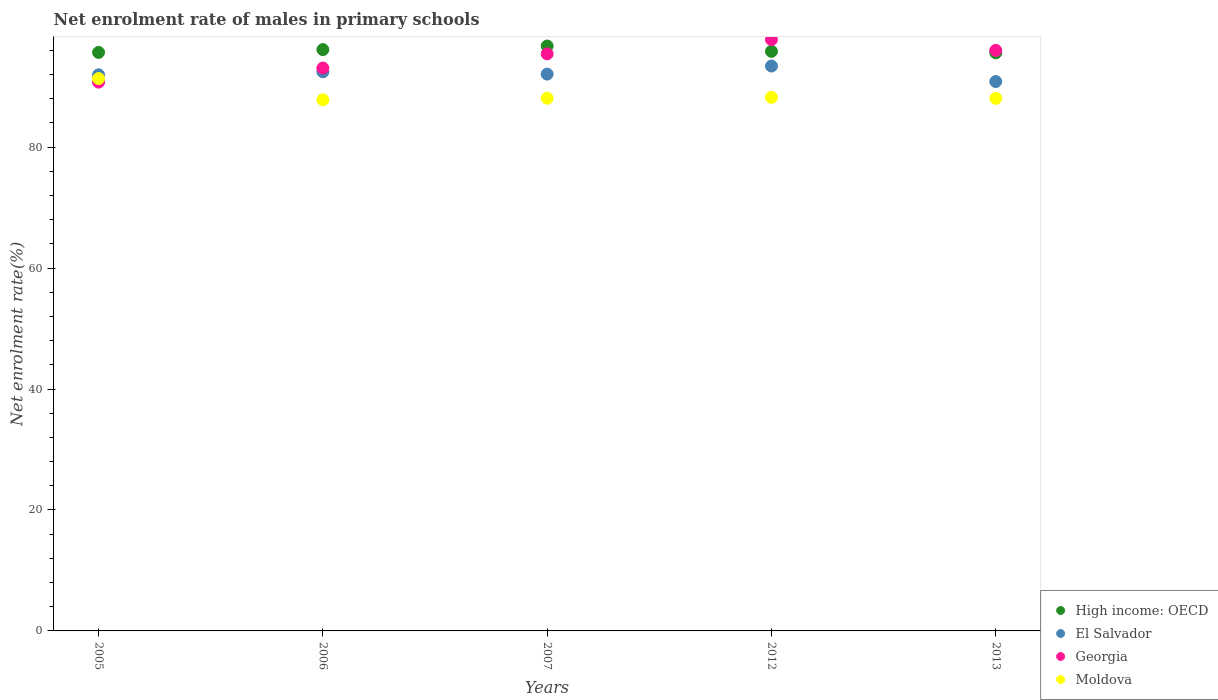How many different coloured dotlines are there?
Provide a short and direct response. 4. What is the net enrolment rate of males in primary schools in High income: OECD in 2005?
Keep it short and to the point. 95.67. Across all years, what is the maximum net enrolment rate of males in primary schools in El Salvador?
Your answer should be compact. 93.41. Across all years, what is the minimum net enrolment rate of males in primary schools in Moldova?
Offer a terse response. 87.82. What is the total net enrolment rate of males in primary schools in High income: OECD in the graph?
Provide a short and direct response. 479.97. What is the difference between the net enrolment rate of males in primary schools in Georgia in 2005 and that in 2007?
Provide a succinct answer. -4.67. What is the difference between the net enrolment rate of males in primary schools in High income: OECD in 2005 and the net enrolment rate of males in primary schools in Moldova in 2007?
Offer a terse response. 7.58. What is the average net enrolment rate of males in primary schools in Moldova per year?
Ensure brevity in your answer.  88.71. In the year 2013, what is the difference between the net enrolment rate of males in primary schools in Georgia and net enrolment rate of males in primary schools in El Salvador?
Provide a short and direct response. 5.15. What is the ratio of the net enrolment rate of males in primary schools in Georgia in 2006 to that in 2012?
Give a very brief answer. 0.95. Is the net enrolment rate of males in primary schools in Georgia in 2007 less than that in 2013?
Give a very brief answer. Yes. What is the difference between the highest and the second highest net enrolment rate of males in primary schools in High income: OECD?
Your answer should be very brief. 0.59. What is the difference between the highest and the lowest net enrolment rate of males in primary schools in Georgia?
Your response must be concise. 7.03. In how many years, is the net enrolment rate of males in primary schools in El Salvador greater than the average net enrolment rate of males in primary schools in El Salvador taken over all years?
Provide a succinct answer. 2. Does the net enrolment rate of males in primary schools in El Salvador monotonically increase over the years?
Make the answer very short. No. Is the net enrolment rate of males in primary schools in Georgia strictly less than the net enrolment rate of males in primary schools in El Salvador over the years?
Ensure brevity in your answer.  No. How many years are there in the graph?
Your answer should be very brief. 5. Does the graph contain any zero values?
Your answer should be very brief. No. Does the graph contain grids?
Your response must be concise. No. What is the title of the graph?
Your answer should be very brief. Net enrolment rate of males in primary schools. What is the label or title of the X-axis?
Your response must be concise. Years. What is the label or title of the Y-axis?
Give a very brief answer. Net enrolment rate(%). What is the Net enrolment rate(%) in High income: OECD in 2005?
Your answer should be compact. 95.67. What is the Net enrolment rate(%) in El Salvador in 2005?
Offer a very short reply. 91.96. What is the Net enrolment rate(%) in Georgia in 2005?
Make the answer very short. 90.75. What is the Net enrolment rate(%) in Moldova in 2005?
Make the answer very short. 91.34. What is the Net enrolment rate(%) of High income: OECD in 2006?
Offer a terse response. 96.13. What is the Net enrolment rate(%) in El Salvador in 2006?
Ensure brevity in your answer.  92.46. What is the Net enrolment rate(%) of Georgia in 2006?
Offer a very short reply. 93.08. What is the Net enrolment rate(%) of Moldova in 2006?
Provide a succinct answer. 87.82. What is the Net enrolment rate(%) of High income: OECD in 2007?
Provide a short and direct response. 96.72. What is the Net enrolment rate(%) in El Salvador in 2007?
Ensure brevity in your answer.  92.08. What is the Net enrolment rate(%) in Georgia in 2007?
Provide a succinct answer. 95.43. What is the Net enrolment rate(%) in Moldova in 2007?
Provide a short and direct response. 88.09. What is the Net enrolment rate(%) in High income: OECD in 2012?
Keep it short and to the point. 95.85. What is the Net enrolment rate(%) in El Salvador in 2012?
Ensure brevity in your answer.  93.41. What is the Net enrolment rate(%) of Georgia in 2012?
Your response must be concise. 97.79. What is the Net enrolment rate(%) in Moldova in 2012?
Keep it short and to the point. 88.23. What is the Net enrolment rate(%) in High income: OECD in 2013?
Your answer should be compact. 95.6. What is the Net enrolment rate(%) of El Salvador in 2013?
Make the answer very short. 90.85. What is the Net enrolment rate(%) of Georgia in 2013?
Your answer should be very brief. 96. What is the Net enrolment rate(%) of Moldova in 2013?
Provide a succinct answer. 88.07. Across all years, what is the maximum Net enrolment rate(%) in High income: OECD?
Provide a succinct answer. 96.72. Across all years, what is the maximum Net enrolment rate(%) of El Salvador?
Your answer should be compact. 93.41. Across all years, what is the maximum Net enrolment rate(%) in Georgia?
Your answer should be very brief. 97.79. Across all years, what is the maximum Net enrolment rate(%) in Moldova?
Your answer should be very brief. 91.34. Across all years, what is the minimum Net enrolment rate(%) of High income: OECD?
Offer a very short reply. 95.6. Across all years, what is the minimum Net enrolment rate(%) of El Salvador?
Offer a very short reply. 90.85. Across all years, what is the minimum Net enrolment rate(%) in Georgia?
Provide a short and direct response. 90.75. Across all years, what is the minimum Net enrolment rate(%) of Moldova?
Offer a terse response. 87.82. What is the total Net enrolment rate(%) in High income: OECD in the graph?
Offer a terse response. 479.97. What is the total Net enrolment rate(%) of El Salvador in the graph?
Offer a very short reply. 460.77. What is the total Net enrolment rate(%) in Georgia in the graph?
Your response must be concise. 473.05. What is the total Net enrolment rate(%) of Moldova in the graph?
Ensure brevity in your answer.  443.55. What is the difference between the Net enrolment rate(%) of High income: OECD in 2005 and that in 2006?
Offer a very short reply. -0.47. What is the difference between the Net enrolment rate(%) of El Salvador in 2005 and that in 2006?
Make the answer very short. -0.5. What is the difference between the Net enrolment rate(%) in Georgia in 2005 and that in 2006?
Make the answer very short. -2.33. What is the difference between the Net enrolment rate(%) in Moldova in 2005 and that in 2006?
Give a very brief answer. 3.52. What is the difference between the Net enrolment rate(%) of High income: OECD in 2005 and that in 2007?
Make the answer very short. -1.06. What is the difference between the Net enrolment rate(%) in El Salvador in 2005 and that in 2007?
Your answer should be compact. -0.12. What is the difference between the Net enrolment rate(%) in Georgia in 2005 and that in 2007?
Keep it short and to the point. -4.67. What is the difference between the Net enrolment rate(%) of Moldova in 2005 and that in 2007?
Offer a very short reply. 3.25. What is the difference between the Net enrolment rate(%) of High income: OECD in 2005 and that in 2012?
Your answer should be very brief. -0.18. What is the difference between the Net enrolment rate(%) of El Salvador in 2005 and that in 2012?
Your response must be concise. -1.45. What is the difference between the Net enrolment rate(%) in Georgia in 2005 and that in 2012?
Give a very brief answer. -7.03. What is the difference between the Net enrolment rate(%) of Moldova in 2005 and that in 2012?
Give a very brief answer. 3.11. What is the difference between the Net enrolment rate(%) of High income: OECD in 2005 and that in 2013?
Make the answer very short. 0.07. What is the difference between the Net enrolment rate(%) of El Salvador in 2005 and that in 2013?
Give a very brief answer. 1.11. What is the difference between the Net enrolment rate(%) in Georgia in 2005 and that in 2013?
Keep it short and to the point. -5.25. What is the difference between the Net enrolment rate(%) in Moldova in 2005 and that in 2013?
Provide a succinct answer. 3.27. What is the difference between the Net enrolment rate(%) of High income: OECD in 2006 and that in 2007?
Your response must be concise. -0.59. What is the difference between the Net enrolment rate(%) of El Salvador in 2006 and that in 2007?
Give a very brief answer. 0.38. What is the difference between the Net enrolment rate(%) of Georgia in 2006 and that in 2007?
Provide a succinct answer. -2.35. What is the difference between the Net enrolment rate(%) of Moldova in 2006 and that in 2007?
Make the answer very short. -0.27. What is the difference between the Net enrolment rate(%) in High income: OECD in 2006 and that in 2012?
Keep it short and to the point. 0.29. What is the difference between the Net enrolment rate(%) in El Salvador in 2006 and that in 2012?
Offer a very short reply. -0.95. What is the difference between the Net enrolment rate(%) in Georgia in 2006 and that in 2012?
Keep it short and to the point. -4.71. What is the difference between the Net enrolment rate(%) of Moldova in 2006 and that in 2012?
Your answer should be compact. -0.41. What is the difference between the Net enrolment rate(%) in High income: OECD in 2006 and that in 2013?
Your response must be concise. 0.54. What is the difference between the Net enrolment rate(%) in El Salvador in 2006 and that in 2013?
Keep it short and to the point. 1.61. What is the difference between the Net enrolment rate(%) in Georgia in 2006 and that in 2013?
Ensure brevity in your answer.  -2.92. What is the difference between the Net enrolment rate(%) of Moldova in 2006 and that in 2013?
Make the answer very short. -0.24. What is the difference between the Net enrolment rate(%) of High income: OECD in 2007 and that in 2012?
Offer a very short reply. 0.88. What is the difference between the Net enrolment rate(%) of El Salvador in 2007 and that in 2012?
Offer a very short reply. -1.33. What is the difference between the Net enrolment rate(%) in Georgia in 2007 and that in 2012?
Provide a short and direct response. -2.36. What is the difference between the Net enrolment rate(%) in Moldova in 2007 and that in 2012?
Ensure brevity in your answer.  -0.14. What is the difference between the Net enrolment rate(%) in High income: OECD in 2007 and that in 2013?
Make the answer very short. 1.13. What is the difference between the Net enrolment rate(%) of El Salvador in 2007 and that in 2013?
Make the answer very short. 1.23. What is the difference between the Net enrolment rate(%) of Georgia in 2007 and that in 2013?
Your answer should be compact. -0.58. What is the difference between the Net enrolment rate(%) of Moldova in 2007 and that in 2013?
Offer a very short reply. 0.02. What is the difference between the Net enrolment rate(%) of High income: OECD in 2012 and that in 2013?
Your answer should be very brief. 0.25. What is the difference between the Net enrolment rate(%) in El Salvador in 2012 and that in 2013?
Your answer should be compact. 2.56. What is the difference between the Net enrolment rate(%) of Georgia in 2012 and that in 2013?
Keep it short and to the point. 1.78. What is the difference between the Net enrolment rate(%) in Moldova in 2012 and that in 2013?
Provide a short and direct response. 0.16. What is the difference between the Net enrolment rate(%) in High income: OECD in 2005 and the Net enrolment rate(%) in El Salvador in 2006?
Make the answer very short. 3.2. What is the difference between the Net enrolment rate(%) in High income: OECD in 2005 and the Net enrolment rate(%) in Georgia in 2006?
Give a very brief answer. 2.58. What is the difference between the Net enrolment rate(%) in High income: OECD in 2005 and the Net enrolment rate(%) in Moldova in 2006?
Ensure brevity in your answer.  7.84. What is the difference between the Net enrolment rate(%) of El Salvador in 2005 and the Net enrolment rate(%) of Georgia in 2006?
Ensure brevity in your answer.  -1.12. What is the difference between the Net enrolment rate(%) of El Salvador in 2005 and the Net enrolment rate(%) of Moldova in 2006?
Provide a short and direct response. 4.14. What is the difference between the Net enrolment rate(%) in Georgia in 2005 and the Net enrolment rate(%) in Moldova in 2006?
Give a very brief answer. 2.93. What is the difference between the Net enrolment rate(%) of High income: OECD in 2005 and the Net enrolment rate(%) of El Salvador in 2007?
Offer a very short reply. 3.58. What is the difference between the Net enrolment rate(%) in High income: OECD in 2005 and the Net enrolment rate(%) in Georgia in 2007?
Provide a short and direct response. 0.24. What is the difference between the Net enrolment rate(%) in High income: OECD in 2005 and the Net enrolment rate(%) in Moldova in 2007?
Give a very brief answer. 7.58. What is the difference between the Net enrolment rate(%) of El Salvador in 2005 and the Net enrolment rate(%) of Georgia in 2007?
Make the answer very short. -3.46. What is the difference between the Net enrolment rate(%) in El Salvador in 2005 and the Net enrolment rate(%) in Moldova in 2007?
Make the answer very short. 3.88. What is the difference between the Net enrolment rate(%) in Georgia in 2005 and the Net enrolment rate(%) in Moldova in 2007?
Give a very brief answer. 2.67. What is the difference between the Net enrolment rate(%) of High income: OECD in 2005 and the Net enrolment rate(%) of El Salvador in 2012?
Keep it short and to the point. 2.25. What is the difference between the Net enrolment rate(%) in High income: OECD in 2005 and the Net enrolment rate(%) in Georgia in 2012?
Make the answer very short. -2.12. What is the difference between the Net enrolment rate(%) of High income: OECD in 2005 and the Net enrolment rate(%) of Moldova in 2012?
Offer a terse response. 7.44. What is the difference between the Net enrolment rate(%) in El Salvador in 2005 and the Net enrolment rate(%) in Georgia in 2012?
Your response must be concise. -5.82. What is the difference between the Net enrolment rate(%) of El Salvador in 2005 and the Net enrolment rate(%) of Moldova in 2012?
Give a very brief answer. 3.73. What is the difference between the Net enrolment rate(%) in Georgia in 2005 and the Net enrolment rate(%) in Moldova in 2012?
Keep it short and to the point. 2.52. What is the difference between the Net enrolment rate(%) of High income: OECD in 2005 and the Net enrolment rate(%) of El Salvador in 2013?
Ensure brevity in your answer.  4.82. What is the difference between the Net enrolment rate(%) of High income: OECD in 2005 and the Net enrolment rate(%) of Georgia in 2013?
Offer a very short reply. -0.34. What is the difference between the Net enrolment rate(%) of High income: OECD in 2005 and the Net enrolment rate(%) of Moldova in 2013?
Offer a terse response. 7.6. What is the difference between the Net enrolment rate(%) in El Salvador in 2005 and the Net enrolment rate(%) in Georgia in 2013?
Your answer should be compact. -4.04. What is the difference between the Net enrolment rate(%) of El Salvador in 2005 and the Net enrolment rate(%) of Moldova in 2013?
Your answer should be very brief. 3.9. What is the difference between the Net enrolment rate(%) of Georgia in 2005 and the Net enrolment rate(%) of Moldova in 2013?
Your answer should be compact. 2.69. What is the difference between the Net enrolment rate(%) in High income: OECD in 2006 and the Net enrolment rate(%) in El Salvador in 2007?
Provide a short and direct response. 4.05. What is the difference between the Net enrolment rate(%) in High income: OECD in 2006 and the Net enrolment rate(%) in Georgia in 2007?
Your response must be concise. 0.71. What is the difference between the Net enrolment rate(%) in High income: OECD in 2006 and the Net enrolment rate(%) in Moldova in 2007?
Your response must be concise. 8.05. What is the difference between the Net enrolment rate(%) of El Salvador in 2006 and the Net enrolment rate(%) of Georgia in 2007?
Give a very brief answer. -2.96. What is the difference between the Net enrolment rate(%) in El Salvador in 2006 and the Net enrolment rate(%) in Moldova in 2007?
Provide a succinct answer. 4.38. What is the difference between the Net enrolment rate(%) of Georgia in 2006 and the Net enrolment rate(%) of Moldova in 2007?
Provide a succinct answer. 4.99. What is the difference between the Net enrolment rate(%) in High income: OECD in 2006 and the Net enrolment rate(%) in El Salvador in 2012?
Ensure brevity in your answer.  2.72. What is the difference between the Net enrolment rate(%) of High income: OECD in 2006 and the Net enrolment rate(%) of Georgia in 2012?
Your response must be concise. -1.65. What is the difference between the Net enrolment rate(%) in High income: OECD in 2006 and the Net enrolment rate(%) in Moldova in 2012?
Provide a succinct answer. 7.9. What is the difference between the Net enrolment rate(%) of El Salvador in 2006 and the Net enrolment rate(%) of Georgia in 2012?
Make the answer very short. -5.32. What is the difference between the Net enrolment rate(%) of El Salvador in 2006 and the Net enrolment rate(%) of Moldova in 2012?
Ensure brevity in your answer.  4.23. What is the difference between the Net enrolment rate(%) in Georgia in 2006 and the Net enrolment rate(%) in Moldova in 2012?
Your answer should be compact. 4.85. What is the difference between the Net enrolment rate(%) in High income: OECD in 2006 and the Net enrolment rate(%) in El Salvador in 2013?
Ensure brevity in your answer.  5.28. What is the difference between the Net enrolment rate(%) of High income: OECD in 2006 and the Net enrolment rate(%) of Georgia in 2013?
Give a very brief answer. 0.13. What is the difference between the Net enrolment rate(%) in High income: OECD in 2006 and the Net enrolment rate(%) in Moldova in 2013?
Your response must be concise. 8.07. What is the difference between the Net enrolment rate(%) in El Salvador in 2006 and the Net enrolment rate(%) in Georgia in 2013?
Your answer should be compact. -3.54. What is the difference between the Net enrolment rate(%) in El Salvador in 2006 and the Net enrolment rate(%) in Moldova in 2013?
Your response must be concise. 4.4. What is the difference between the Net enrolment rate(%) of Georgia in 2006 and the Net enrolment rate(%) of Moldova in 2013?
Provide a succinct answer. 5.01. What is the difference between the Net enrolment rate(%) in High income: OECD in 2007 and the Net enrolment rate(%) in El Salvador in 2012?
Keep it short and to the point. 3.31. What is the difference between the Net enrolment rate(%) in High income: OECD in 2007 and the Net enrolment rate(%) in Georgia in 2012?
Provide a succinct answer. -1.06. What is the difference between the Net enrolment rate(%) of High income: OECD in 2007 and the Net enrolment rate(%) of Moldova in 2012?
Ensure brevity in your answer.  8.49. What is the difference between the Net enrolment rate(%) in El Salvador in 2007 and the Net enrolment rate(%) in Georgia in 2012?
Your answer should be very brief. -5.7. What is the difference between the Net enrolment rate(%) of El Salvador in 2007 and the Net enrolment rate(%) of Moldova in 2012?
Provide a short and direct response. 3.85. What is the difference between the Net enrolment rate(%) of Georgia in 2007 and the Net enrolment rate(%) of Moldova in 2012?
Your answer should be compact. 7.2. What is the difference between the Net enrolment rate(%) in High income: OECD in 2007 and the Net enrolment rate(%) in El Salvador in 2013?
Provide a short and direct response. 5.87. What is the difference between the Net enrolment rate(%) of High income: OECD in 2007 and the Net enrolment rate(%) of Georgia in 2013?
Offer a very short reply. 0.72. What is the difference between the Net enrolment rate(%) of High income: OECD in 2007 and the Net enrolment rate(%) of Moldova in 2013?
Your answer should be very brief. 8.66. What is the difference between the Net enrolment rate(%) of El Salvador in 2007 and the Net enrolment rate(%) of Georgia in 2013?
Make the answer very short. -3.92. What is the difference between the Net enrolment rate(%) of El Salvador in 2007 and the Net enrolment rate(%) of Moldova in 2013?
Give a very brief answer. 4.02. What is the difference between the Net enrolment rate(%) in Georgia in 2007 and the Net enrolment rate(%) in Moldova in 2013?
Ensure brevity in your answer.  7.36. What is the difference between the Net enrolment rate(%) in High income: OECD in 2012 and the Net enrolment rate(%) in El Salvador in 2013?
Provide a succinct answer. 5. What is the difference between the Net enrolment rate(%) in High income: OECD in 2012 and the Net enrolment rate(%) in Georgia in 2013?
Ensure brevity in your answer.  -0.16. What is the difference between the Net enrolment rate(%) in High income: OECD in 2012 and the Net enrolment rate(%) in Moldova in 2013?
Give a very brief answer. 7.78. What is the difference between the Net enrolment rate(%) in El Salvador in 2012 and the Net enrolment rate(%) in Georgia in 2013?
Your response must be concise. -2.59. What is the difference between the Net enrolment rate(%) of El Salvador in 2012 and the Net enrolment rate(%) of Moldova in 2013?
Provide a succinct answer. 5.34. What is the difference between the Net enrolment rate(%) in Georgia in 2012 and the Net enrolment rate(%) in Moldova in 2013?
Provide a short and direct response. 9.72. What is the average Net enrolment rate(%) in High income: OECD per year?
Give a very brief answer. 95.99. What is the average Net enrolment rate(%) in El Salvador per year?
Keep it short and to the point. 92.15. What is the average Net enrolment rate(%) of Georgia per year?
Your answer should be very brief. 94.61. What is the average Net enrolment rate(%) in Moldova per year?
Ensure brevity in your answer.  88.71. In the year 2005, what is the difference between the Net enrolment rate(%) in High income: OECD and Net enrolment rate(%) in El Salvador?
Offer a very short reply. 3.7. In the year 2005, what is the difference between the Net enrolment rate(%) in High income: OECD and Net enrolment rate(%) in Georgia?
Offer a very short reply. 4.91. In the year 2005, what is the difference between the Net enrolment rate(%) of High income: OECD and Net enrolment rate(%) of Moldova?
Your answer should be compact. 4.33. In the year 2005, what is the difference between the Net enrolment rate(%) in El Salvador and Net enrolment rate(%) in Georgia?
Give a very brief answer. 1.21. In the year 2005, what is the difference between the Net enrolment rate(%) in El Salvador and Net enrolment rate(%) in Moldova?
Provide a succinct answer. 0.62. In the year 2005, what is the difference between the Net enrolment rate(%) in Georgia and Net enrolment rate(%) in Moldova?
Offer a very short reply. -0.59. In the year 2006, what is the difference between the Net enrolment rate(%) in High income: OECD and Net enrolment rate(%) in El Salvador?
Your response must be concise. 3.67. In the year 2006, what is the difference between the Net enrolment rate(%) of High income: OECD and Net enrolment rate(%) of Georgia?
Ensure brevity in your answer.  3.05. In the year 2006, what is the difference between the Net enrolment rate(%) in High income: OECD and Net enrolment rate(%) in Moldova?
Your response must be concise. 8.31. In the year 2006, what is the difference between the Net enrolment rate(%) in El Salvador and Net enrolment rate(%) in Georgia?
Your response must be concise. -0.62. In the year 2006, what is the difference between the Net enrolment rate(%) in El Salvador and Net enrolment rate(%) in Moldova?
Provide a short and direct response. 4.64. In the year 2006, what is the difference between the Net enrolment rate(%) of Georgia and Net enrolment rate(%) of Moldova?
Your answer should be compact. 5.26. In the year 2007, what is the difference between the Net enrolment rate(%) in High income: OECD and Net enrolment rate(%) in El Salvador?
Keep it short and to the point. 4.64. In the year 2007, what is the difference between the Net enrolment rate(%) in High income: OECD and Net enrolment rate(%) in Georgia?
Provide a short and direct response. 1.3. In the year 2007, what is the difference between the Net enrolment rate(%) of High income: OECD and Net enrolment rate(%) of Moldova?
Your response must be concise. 8.64. In the year 2007, what is the difference between the Net enrolment rate(%) of El Salvador and Net enrolment rate(%) of Georgia?
Offer a very short reply. -3.35. In the year 2007, what is the difference between the Net enrolment rate(%) in El Salvador and Net enrolment rate(%) in Moldova?
Keep it short and to the point. 3.99. In the year 2007, what is the difference between the Net enrolment rate(%) in Georgia and Net enrolment rate(%) in Moldova?
Make the answer very short. 7.34. In the year 2012, what is the difference between the Net enrolment rate(%) of High income: OECD and Net enrolment rate(%) of El Salvador?
Offer a very short reply. 2.43. In the year 2012, what is the difference between the Net enrolment rate(%) of High income: OECD and Net enrolment rate(%) of Georgia?
Keep it short and to the point. -1.94. In the year 2012, what is the difference between the Net enrolment rate(%) in High income: OECD and Net enrolment rate(%) in Moldova?
Keep it short and to the point. 7.62. In the year 2012, what is the difference between the Net enrolment rate(%) in El Salvador and Net enrolment rate(%) in Georgia?
Your response must be concise. -4.38. In the year 2012, what is the difference between the Net enrolment rate(%) of El Salvador and Net enrolment rate(%) of Moldova?
Keep it short and to the point. 5.18. In the year 2012, what is the difference between the Net enrolment rate(%) of Georgia and Net enrolment rate(%) of Moldova?
Your response must be concise. 9.56. In the year 2013, what is the difference between the Net enrolment rate(%) in High income: OECD and Net enrolment rate(%) in El Salvador?
Provide a succinct answer. 4.75. In the year 2013, what is the difference between the Net enrolment rate(%) of High income: OECD and Net enrolment rate(%) of Georgia?
Your answer should be compact. -0.41. In the year 2013, what is the difference between the Net enrolment rate(%) in High income: OECD and Net enrolment rate(%) in Moldova?
Keep it short and to the point. 7.53. In the year 2013, what is the difference between the Net enrolment rate(%) of El Salvador and Net enrolment rate(%) of Georgia?
Your answer should be compact. -5.15. In the year 2013, what is the difference between the Net enrolment rate(%) of El Salvador and Net enrolment rate(%) of Moldova?
Offer a terse response. 2.78. In the year 2013, what is the difference between the Net enrolment rate(%) of Georgia and Net enrolment rate(%) of Moldova?
Give a very brief answer. 7.94. What is the ratio of the Net enrolment rate(%) in Moldova in 2005 to that in 2006?
Keep it short and to the point. 1.04. What is the ratio of the Net enrolment rate(%) of High income: OECD in 2005 to that in 2007?
Offer a very short reply. 0.99. What is the ratio of the Net enrolment rate(%) in El Salvador in 2005 to that in 2007?
Give a very brief answer. 1. What is the ratio of the Net enrolment rate(%) in Georgia in 2005 to that in 2007?
Offer a terse response. 0.95. What is the ratio of the Net enrolment rate(%) of Moldova in 2005 to that in 2007?
Offer a very short reply. 1.04. What is the ratio of the Net enrolment rate(%) of El Salvador in 2005 to that in 2012?
Your answer should be compact. 0.98. What is the ratio of the Net enrolment rate(%) of Georgia in 2005 to that in 2012?
Make the answer very short. 0.93. What is the ratio of the Net enrolment rate(%) of Moldova in 2005 to that in 2012?
Provide a succinct answer. 1.04. What is the ratio of the Net enrolment rate(%) in High income: OECD in 2005 to that in 2013?
Keep it short and to the point. 1. What is the ratio of the Net enrolment rate(%) in El Salvador in 2005 to that in 2013?
Make the answer very short. 1.01. What is the ratio of the Net enrolment rate(%) of Georgia in 2005 to that in 2013?
Provide a short and direct response. 0.95. What is the ratio of the Net enrolment rate(%) of Moldova in 2005 to that in 2013?
Your answer should be compact. 1.04. What is the ratio of the Net enrolment rate(%) of El Salvador in 2006 to that in 2007?
Give a very brief answer. 1. What is the ratio of the Net enrolment rate(%) in Georgia in 2006 to that in 2007?
Ensure brevity in your answer.  0.98. What is the ratio of the Net enrolment rate(%) of High income: OECD in 2006 to that in 2012?
Your response must be concise. 1. What is the ratio of the Net enrolment rate(%) in Georgia in 2006 to that in 2012?
Keep it short and to the point. 0.95. What is the ratio of the Net enrolment rate(%) in Moldova in 2006 to that in 2012?
Your response must be concise. 1. What is the ratio of the Net enrolment rate(%) in High income: OECD in 2006 to that in 2013?
Your response must be concise. 1.01. What is the ratio of the Net enrolment rate(%) of El Salvador in 2006 to that in 2013?
Give a very brief answer. 1.02. What is the ratio of the Net enrolment rate(%) of Georgia in 2006 to that in 2013?
Your response must be concise. 0.97. What is the ratio of the Net enrolment rate(%) in Moldova in 2006 to that in 2013?
Keep it short and to the point. 1. What is the ratio of the Net enrolment rate(%) of High income: OECD in 2007 to that in 2012?
Keep it short and to the point. 1.01. What is the ratio of the Net enrolment rate(%) of El Salvador in 2007 to that in 2012?
Offer a terse response. 0.99. What is the ratio of the Net enrolment rate(%) of Georgia in 2007 to that in 2012?
Keep it short and to the point. 0.98. What is the ratio of the Net enrolment rate(%) in Moldova in 2007 to that in 2012?
Provide a succinct answer. 1. What is the ratio of the Net enrolment rate(%) in High income: OECD in 2007 to that in 2013?
Your response must be concise. 1.01. What is the ratio of the Net enrolment rate(%) in El Salvador in 2007 to that in 2013?
Keep it short and to the point. 1.01. What is the ratio of the Net enrolment rate(%) of Georgia in 2007 to that in 2013?
Keep it short and to the point. 0.99. What is the ratio of the Net enrolment rate(%) of Moldova in 2007 to that in 2013?
Give a very brief answer. 1. What is the ratio of the Net enrolment rate(%) in El Salvador in 2012 to that in 2013?
Give a very brief answer. 1.03. What is the ratio of the Net enrolment rate(%) in Georgia in 2012 to that in 2013?
Your response must be concise. 1.02. What is the ratio of the Net enrolment rate(%) in Moldova in 2012 to that in 2013?
Your answer should be compact. 1. What is the difference between the highest and the second highest Net enrolment rate(%) in High income: OECD?
Provide a succinct answer. 0.59. What is the difference between the highest and the second highest Net enrolment rate(%) in El Salvador?
Your answer should be very brief. 0.95. What is the difference between the highest and the second highest Net enrolment rate(%) in Georgia?
Your answer should be compact. 1.78. What is the difference between the highest and the second highest Net enrolment rate(%) in Moldova?
Keep it short and to the point. 3.11. What is the difference between the highest and the lowest Net enrolment rate(%) in High income: OECD?
Keep it short and to the point. 1.13. What is the difference between the highest and the lowest Net enrolment rate(%) in El Salvador?
Your answer should be very brief. 2.56. What is the difference between the highest and the lowest Net enrolment rate(%) of Georgia?
Provide a succinct answer. 7.03. What is the difference between the highest and the lowest Net enrolment rate(%) of Moldova?
Provide a succinct answer. 3.52. 